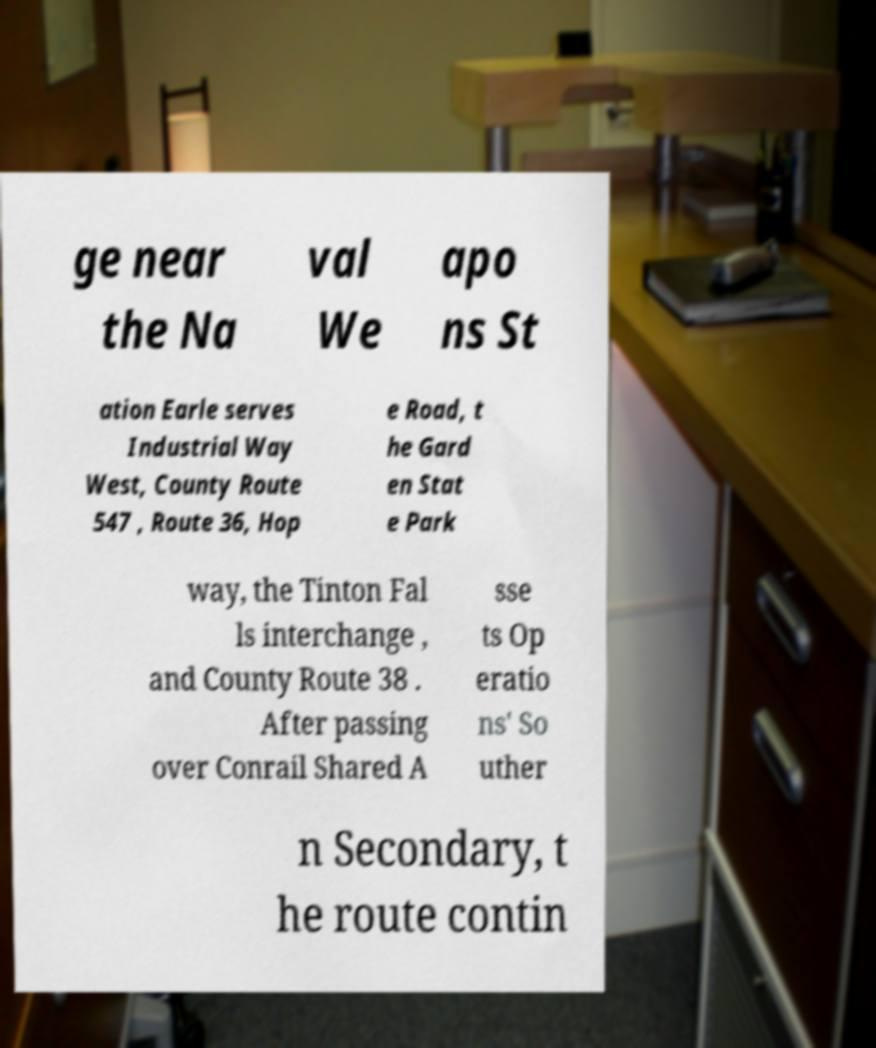I need the written content from this picture converted into text. Can you do that? ge near the Na val We apo ns St ation Earle serves Industrial Way West, County Route 547 , Route 36, Hop e Road, t he Gard en Stat e Park way, the Tinton Fal ls interchange , and County Route 38 . After passing over Conrail Shared A sse ts Op eratio ns' So uther n Secondary, t he route contin 